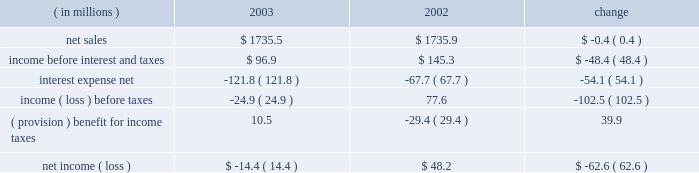Other expense , net , decreased $ 6.2 million , or 50.0% ( 50.0 % ) , for the year ended december 31 , 2004 compared to the year ended december 31 , 2003 .
The decrease was primarily due to a reduction in charges on disposal and transfer costs of fixed assets and facility closure costs of $ 3.3 million , reduced legal charges of $ 1.5 million , and a reduction in expenses of $ 1.4 million consisting of individually insignificant items .
Interest expense and income taxes interest expense decreased in 2004 by $ 92.2 million , or 75.7% ( 75.7 % ) , from 2003 .
This decrease included $ 73.3 million of expenses related to the company 2019s debt refinancing , which was completed in july 2003 .
The $ 73.3 million of expenses consisted of $ 55.9 million paid in premiums for the tender of the 95 20448% ( 20448 % ) senior subordinated notes , and a $ 17.4 million non-cash charge for the write-off of deferred financing fees related to the 95 20448% ( 20448 % ) notes and pca 2019s original revolving credit facility .
Excluding the $ 73.3 million charge , interest expense was $ 18.9 million lower than in 2003 as a result of lower interest rates attributable to the company 2019s july 2003 refinancing and lower debt levels .
Pca 2019s effective tax rate was 38.0% ( 38.0 % ) for the year ended december 31 , 2004 and 42.3% ( 42.3 % ) for the year ended december 31 , 2003 .
The higher tax rate in 2003 is due to stable permanent items over lower book income ( loss ) .
For both years 2004 and 2003 tax rates are higher than the federal statutory rate of 35.0% ( 35.0 % ) due to state income taxes .
Year ended december 31 , 2003 compared to year ended december 31 , 2002 the historical results of operations of pca for the years ended december 31 , 2003 and 2002 are set forth below : for the year ended december 31 , ( in millions ) 2003 2002 change .
Net sales net sales decreased by $ 0.4 million , or 0.0% ( 0.0 % ) , for the year ended december 31 , 2003 from the year ended december 31 , 2002 .
Net sales increased due to improved sales volumes compared to 2002 , however , this increase was entirely offset by lower sales prices .
Total corrugated products volume sold increased 2.1% ( 2.1 % ) to 28.1 billion square feet in 2003 compared to 27.5 billion square feet in 2002 .
On a comparable shipment-per-workday basis , corrugated products sales volume increased 1.7% ( 1.7 % ) in 2003 from 2002 .
Shipments-per-workday is calculated by dividing our total corrugated products volume during the year by the number of workdays within the year .
The lower percentage increase was due to the fact that 2003 had one more workday ( 252 days ) , those days not falling on a weekend or holiday , than 2002 ( 251 days ) .
Containerboard sales volume to external domestic and export customers decreased 6.7% ( 6.7 % ) to 445000 tons for the year ended december 31 , 2003 from 477000 tons in the comparable period of 2002 .
Income before interest and taxes income before interest and taxes decreased by $ 48.4 million , or 33.3% ( 33.3 % ) , for the year ended december 31 , 2003 compared to 2002 .
Included in income before interest and taxes for the twelve months .
Containerboard sales volume to external domestic and export customers decreased by how many tons in the year ended december 31 , 2003 from 2002? 
Computations: (477000 - 445000)
Answer: 32000.0. Other expense , net , decreased $ 6.2 million , or 50.0% ( 50.0 % ) , for the year ended december 31 , 2004 compared to the year ended december 31 , 2003 .
The decrease was primarily due to a reduction in charges on disposal and transfer costs of fixed assets and facility closure costs of $ 3.3 million , reduced legal charges of $ 1.5 million , and a reduction in expenses of $ 1.4 million consisting of individually insignificant items .
Interest expense and income taxes interest expense decreased in 2004 by $ 92.2 million , or 75.7% ( 75.7 % ) , from 2003 .
This decrease included $ 73.3 million of expenses related to the company 2019s debt refinancing , which was completed in july 2003 .
The $ 73.3 million of expenses consisted of $ 55.9 million paid in premiums for the tender of the 95 20448% ( 20448 % ) senior subordinated notes , and a $ 17.4 million non-cash charge for the write-off of deferred financing fees related to the 95 20448% ( 20448 % ) notes and pca 2019s original revolving credit facility .
Excluding the $ 73.3 million charge , interest expense was $ 18.9 million lower than in 2003 as a result of lower interest rates attributable to the company 2019s july 2003 refinancing and lower debt levels .
Pca 2019s effective tax rate was 38.0% ( 38.0 % ) for the year ended december 31 , 2004 and 42.3% ( 42.3 % ) for the year ended december 31 , 2003 .
The higher tax rate in 2003 is due to stable permanent items over lower book income ( loss ) .
For both years 2004 and 2003 tax rates are higher than the federal statutory rate of 35.0% ( 35.0 % ) due to state income taxes .
Year ended december 31 , 2003 compared to year ended december 31 , 2002 the historical results of operations of pca for the years ended december 31 , 2003 and 2002 are set forth below : for the year ended december 31 , ( in millions ) 2003 2002 change .
Net sales net sales decreased by $ 0.4 million , or 0.0% ( 0.0 % ) , for the year ended december 31 , 2003 from the year ended december 31 , 2002 .
Net sales increased due to improved sales volumes compared to 2002 , however , this increase was entirely offset by lower sales prices .
Total corrugated products volume sold increased 2.1% ( 2.1 % ) to 28.1 billion square feet in 2003 compared to 27.5 billion square feet in 2002 .
On a comparable shipment-per-workday basis , corrugated products sales volume increased 1.7% ( 1.7 % ) in 2003 from 2002 .
Shipments-per-workday is calculated by dividing our total corrugated products volume during the year by the number of workdays within the year .
The lower percentage increase was due to the fact that 2003 had one more workday ( 252 days ) , those days not falling on a weekend or holiday , than 2002 ( 251 days ) .
Containerboard sales volume to external domestic and export customers decreased 6.7% ( 6.7 % ) to 445000 tons for the year ended december 31 , 2003 from 477000 tons in the comparable period of 2002 .
Income before interest and taxes income before interest and taxes decreased by $ 48.4 million , or 33.3% ( 33.3 % ) , for the year ended december 31 , 2003 compared to 2002 .
Included in income before interest and taxes for the twelve months .
What was the percentage point change in pca 2019s effective tax rate in december 31 , 2004 from december 31 , 2003? 
Computations: (42.3 - 38.0)
Answer: 4.3. 